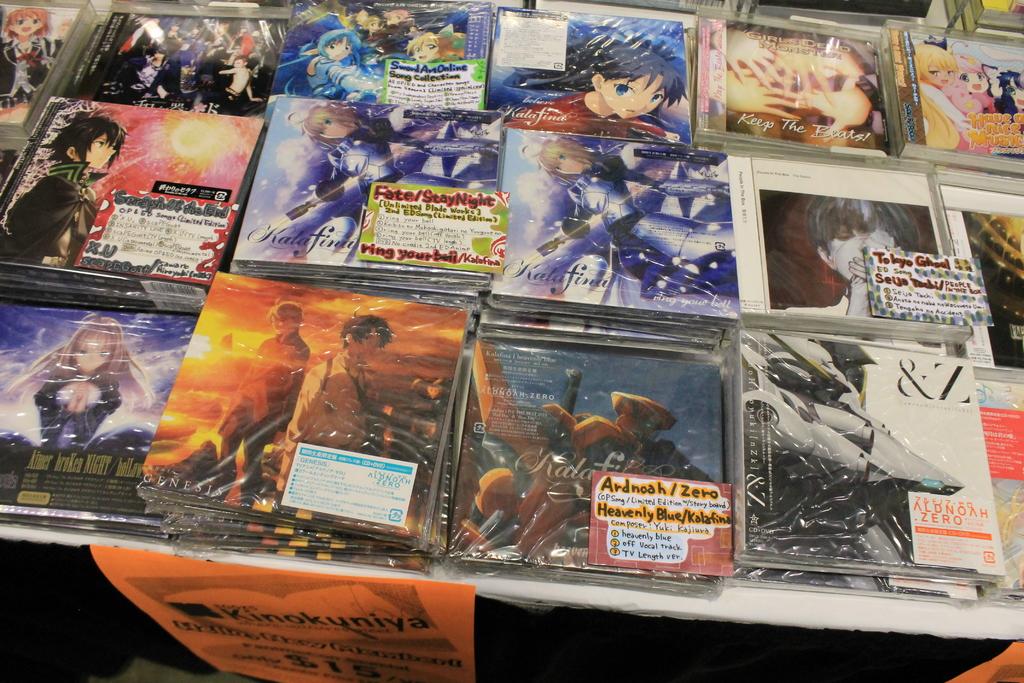Is there a fate/stay night album in this?
Make the answer very short. Yes. Which symbol is contained on the last title to the right on the bottom?
Your response must be concise. &. 